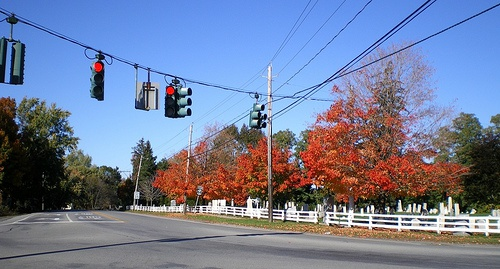Describe the objects in this image and their specific colors. I can see traffic light in blue, black, gray, teal, and navy tones, traffic light in blue, darkgray, navy, and black tones, traffic light in blue, black, gray, red, and navy tones, traffic light in blue, black, red, and navy tones, and traffic light in blue, black, teal, and lightblue tones in this image. 